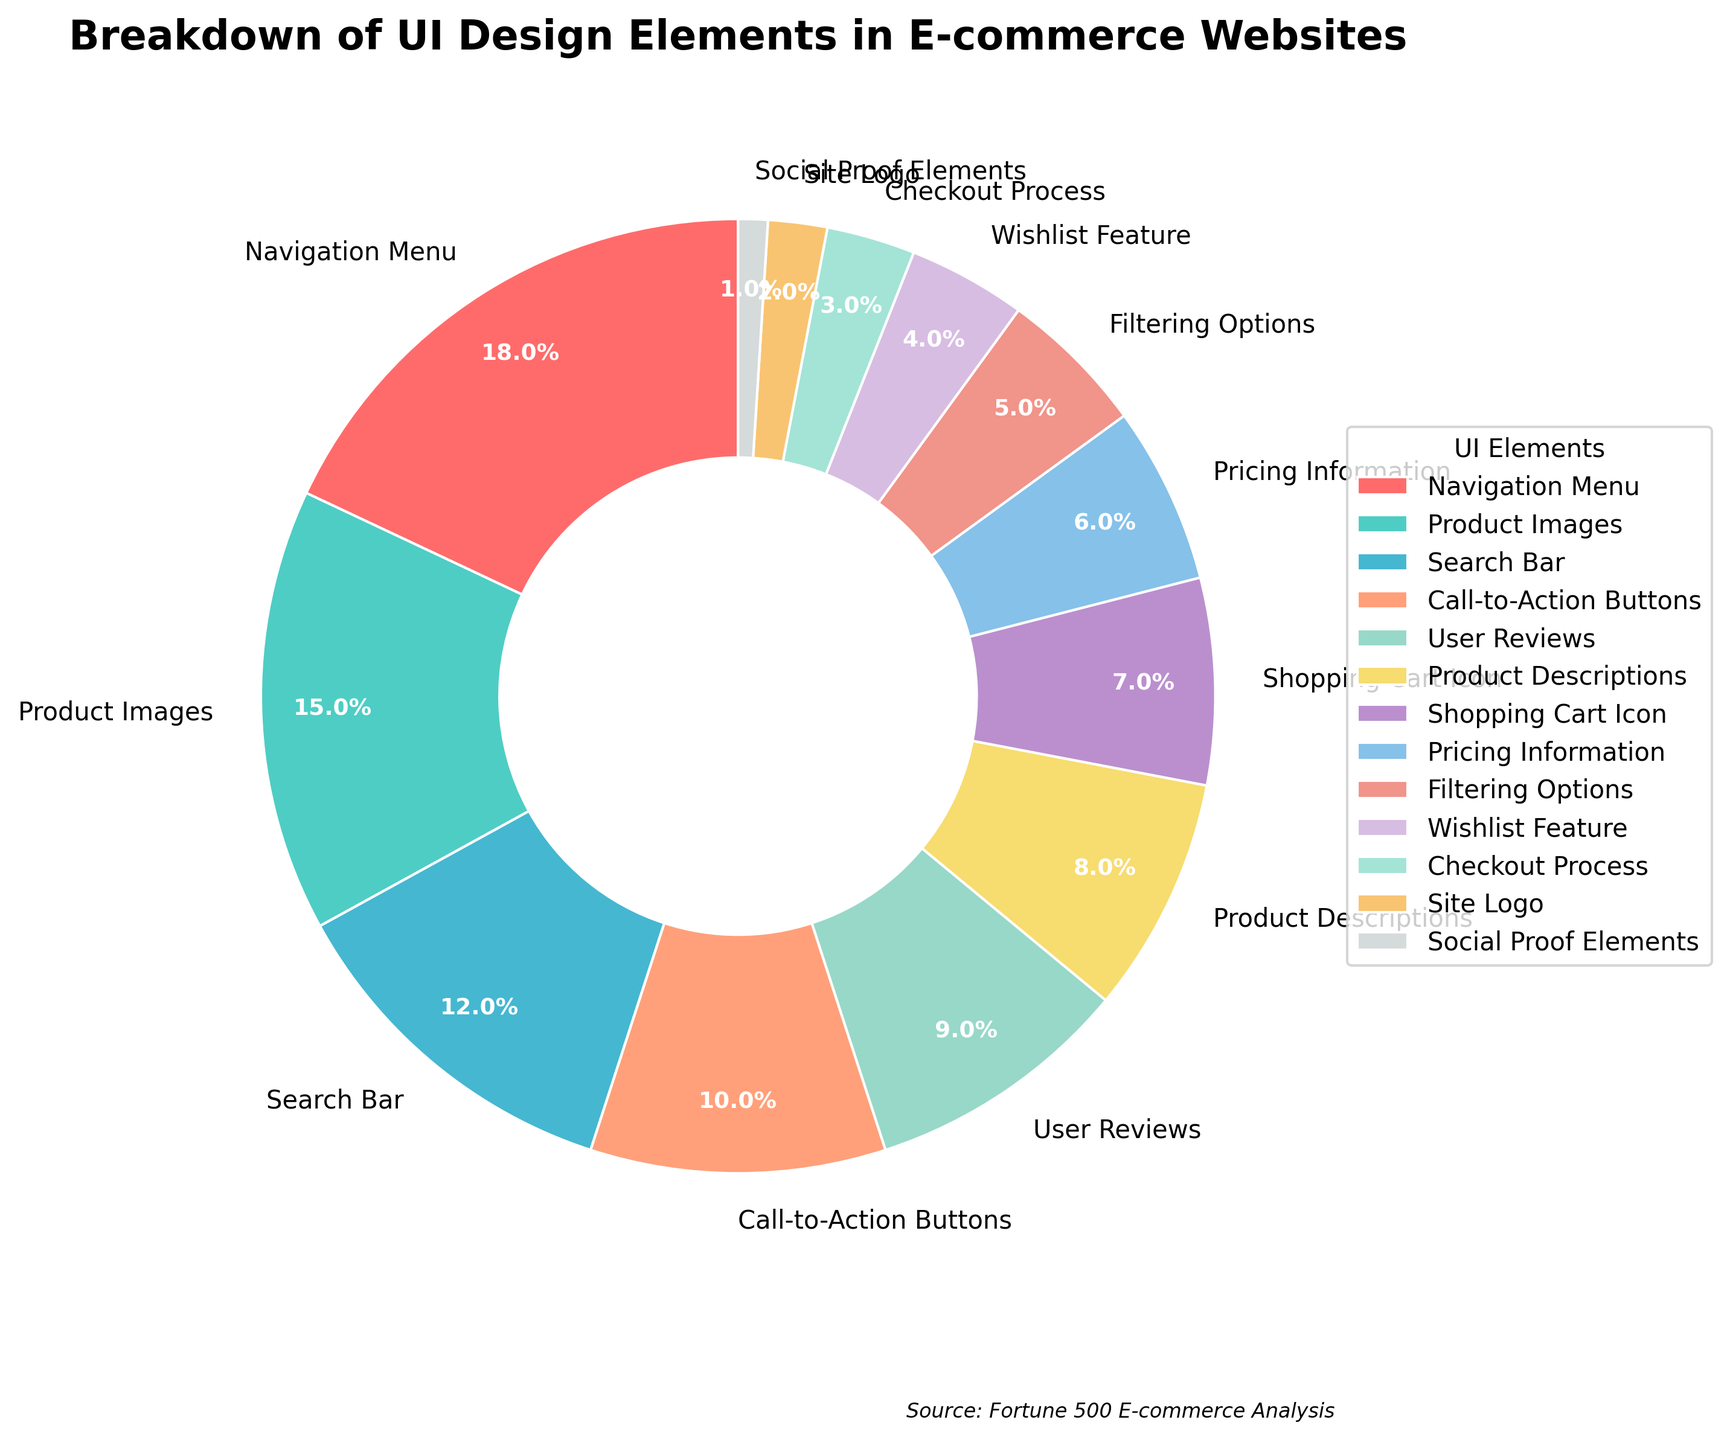What percentage of the pie chart is represented by Navigation Menu and Product Images combined? To find the combined percentage for Navigation Menu and Product Images, add their individual percentages: 18% + 15% = 33%
Answer: 33% Which element has a smaller percentage, Call-to-Action Buttons or User Reviews? Compare the percentages of Call-to-Action Buttons (10%) and User Reviews (9%). 9% is smaller than 10%
Answer: User Reviews How much larger is the percentage for Navigation Menu compared to the Search Bar? Subtract the percentage of the Search Bar (12%) from the percentage of the Navigation Menu (18%): 18% - 12% = 6%
Answer: 6% List all elements that individually take up less than 5% of the pie chart. Identify elements with a percentage under 5%: Wishlist Feature (4%), Checkout Process (3%), Site Logo (2%), Social Proof Elements (1%)
Answer: Wishlist Feature, Checkout Process, Site Logo, Social Proof Elements What is the total percentage of elements related to product information (Product Images, Product Descriptions, Pricing Information)? Add the percentages of Product Images (15%), Product Descriptions (8%), and Pricing Information (6%): 15% + 8% + 6% = 29%
Answer: 29% Compare the combined percentage of Filtering Options and Wishlist Feature to that of the Shopping Cart Icon. Which is larger? Add the percentages of Filtering Options (5%) and Wishlist Feature (4%), then compare to the Shopping Cart Icon (7%): 5% + 4% = 9%, which is larger than 7%
Answer: Combined Filtering Options and Wishlist Feature What color represents the section for User Reviews? Identify the color assigned to User Reviews. User Reviews is immediately after Call-to-Action Buttons and is shown in a light greenish-blue color
Answer: Light greenish-blue 